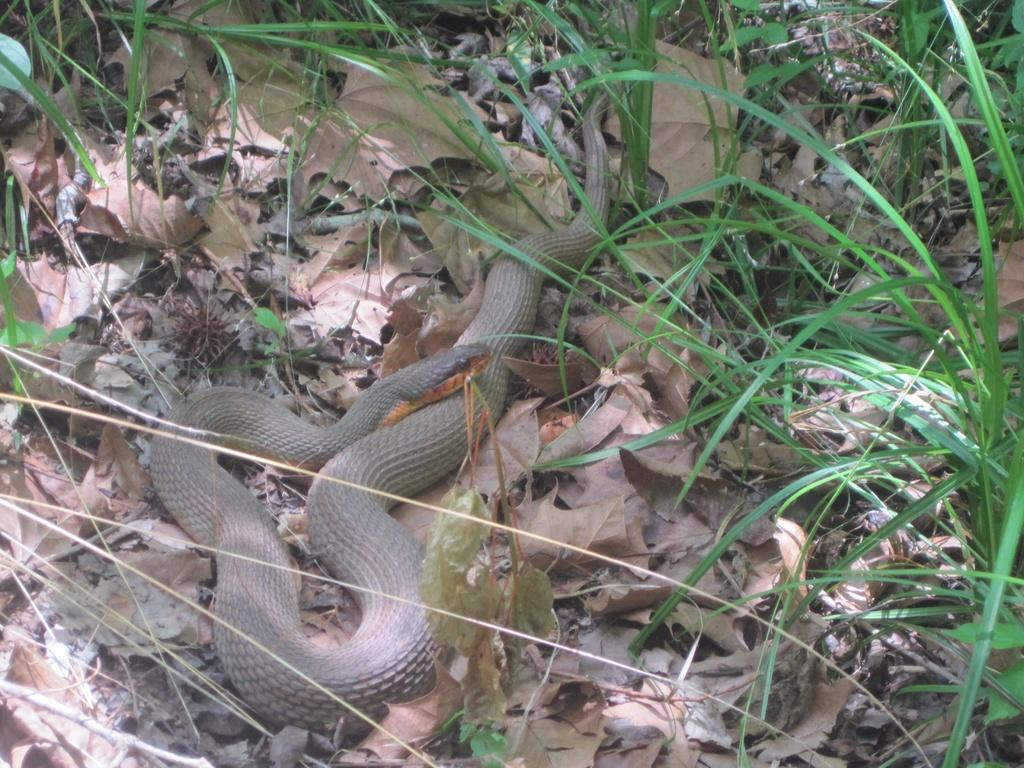What type of animal is present in the image? There is a snake in the image. What type of vegetation can be seen in the image? There are leaves and grass in the image. What type of chalk is the snake using to draw in the image? There is no chalk or drawing activity present in the image. Where is the oven located in the image? There is no oven present in the image. 